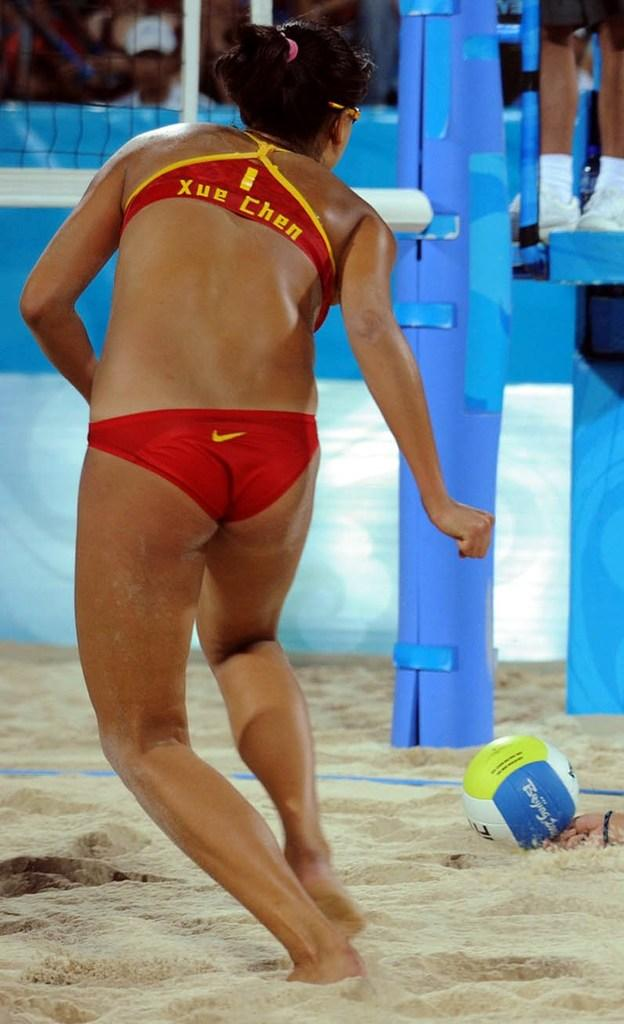Who is the main subject in the image? There is a woman in the image. What is the woman doing in the image? The woman is running. What object can be seen in the image? There is a ball in the image. What type of terrain is visible in the image? Sand is present in the image. How many people are in the image? There is one person in the image, the woman. What can be seen in the background of the image? There are people and a net in the background of the image. What type of hobbies can be seen being practiced in space in the image? There is no reference to space or any hobbies being practiced in the image; it features a woman running on sand with a ball and a net in the background. 